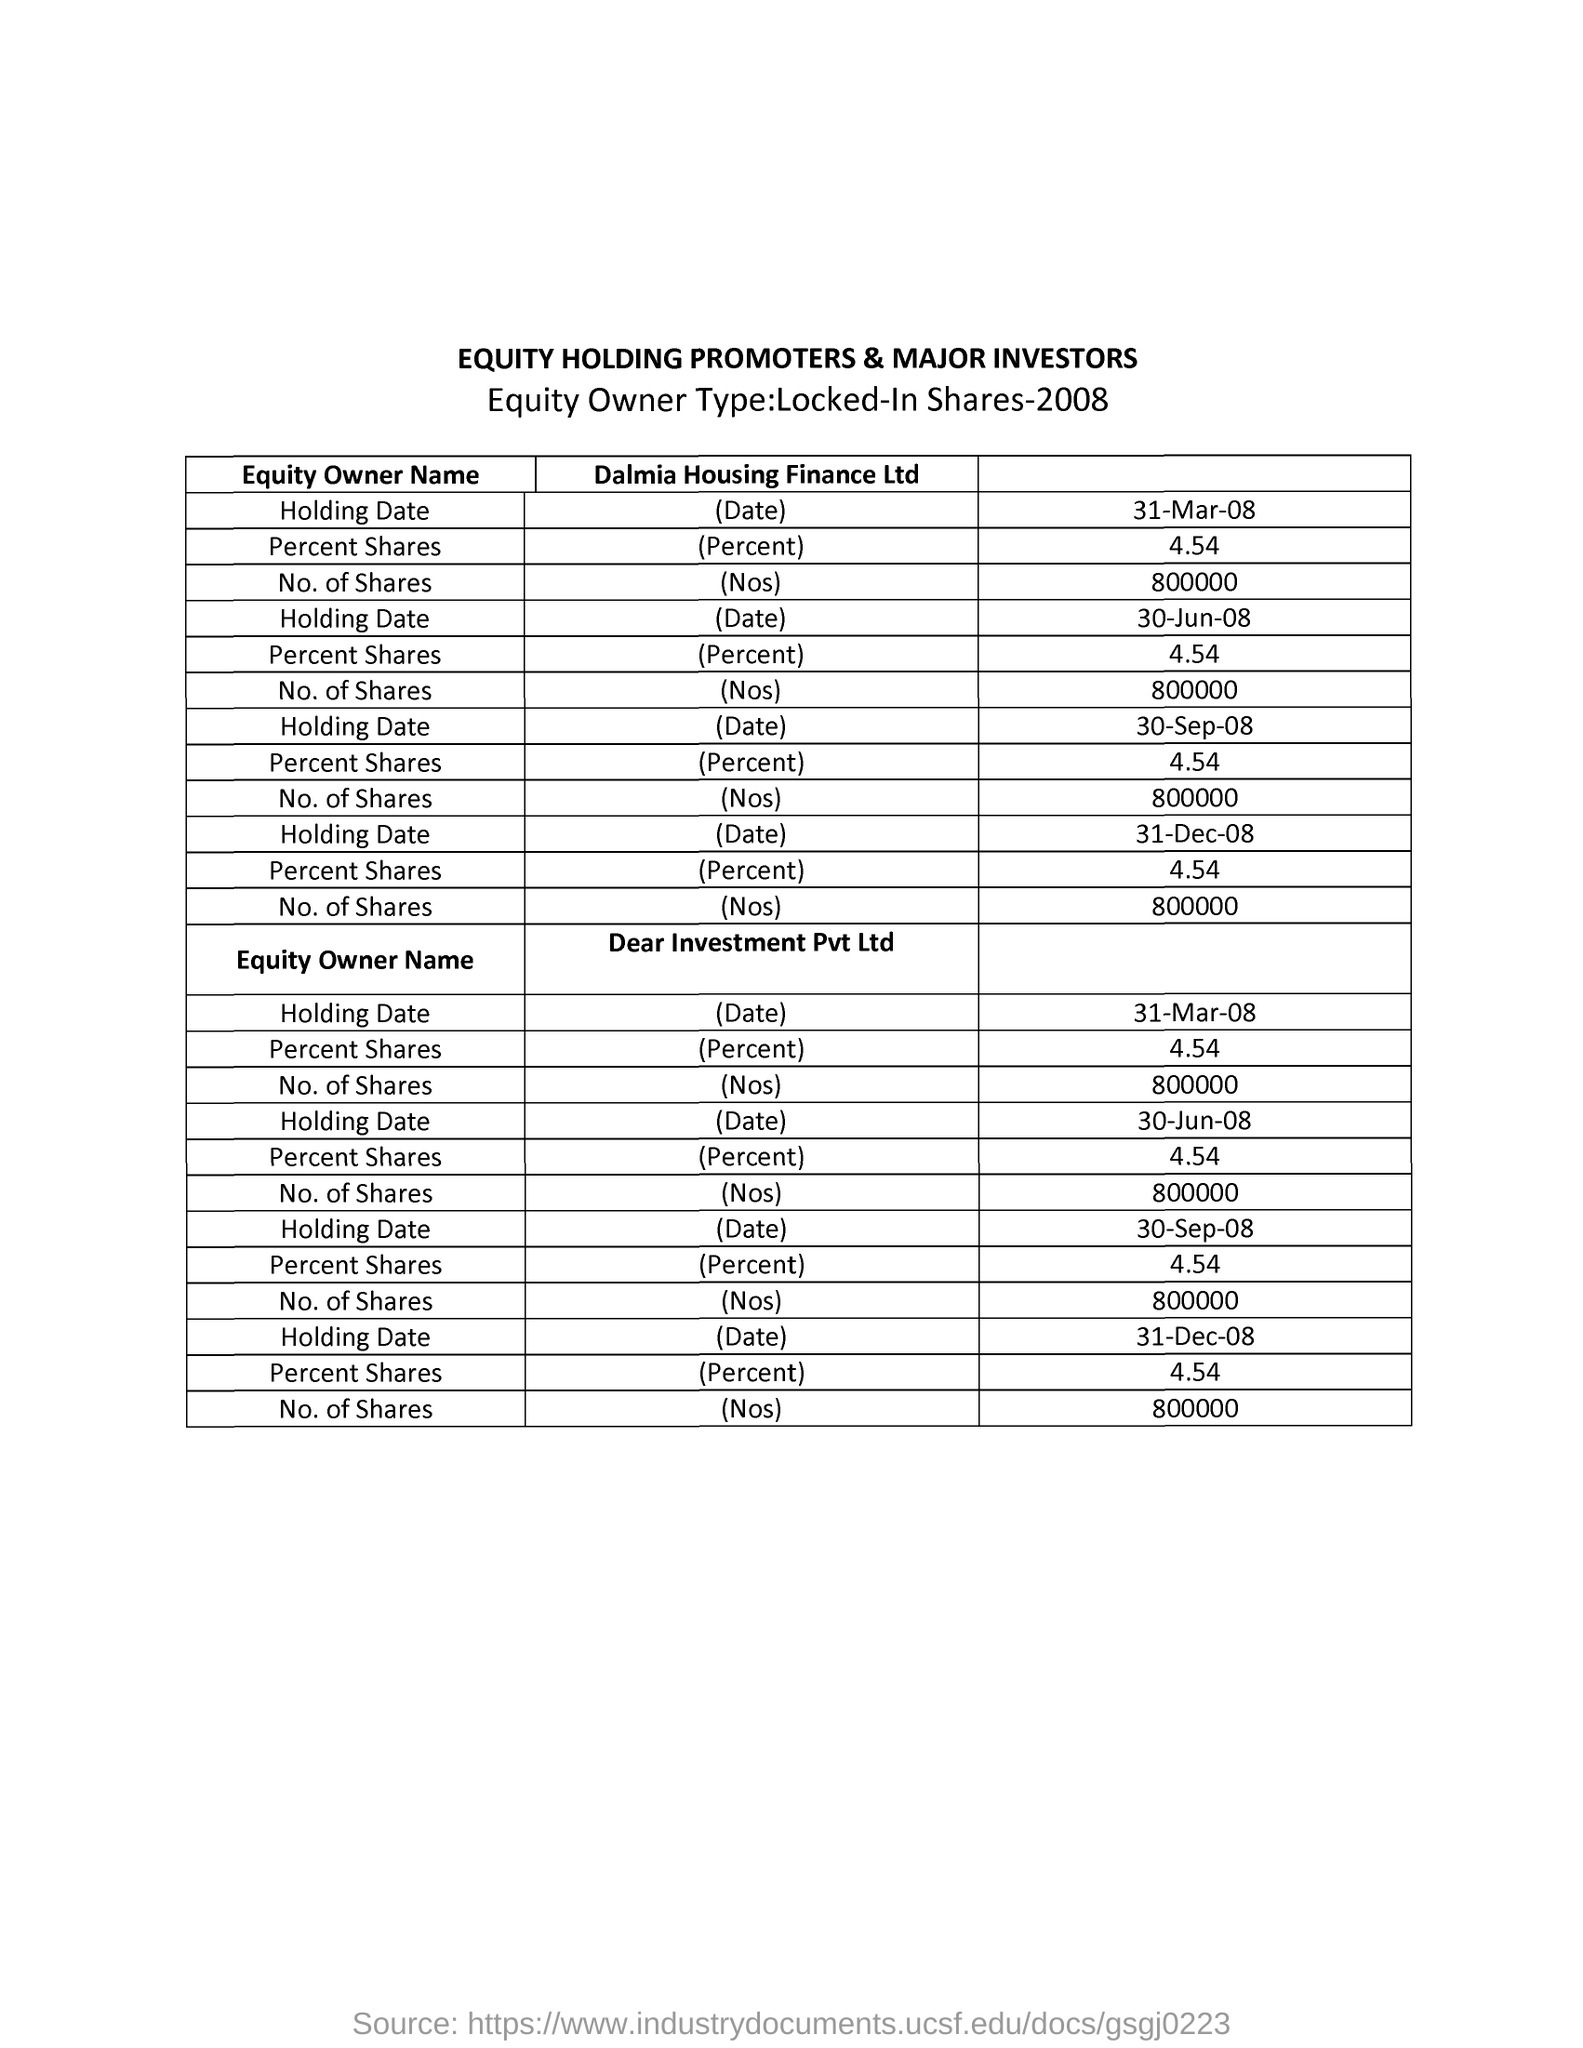What is the heading of the table written in capital letters?
Your answer should be compact. EQUITY HOLDING PROMOTERS & MAJOR INVESTORS. What is the first column heading of the table?
Your answer should be very brief. Equity Owner Name. What is the second column heading of the first table?
Offer a very short reply. Dalmia Housing Finance Ltd. For the "Holding Date " of 31-Mar-08 what PERCENT SHARES is given by "Dalmia Housing Finance Ltd"?
Offer a terse response. 4.54. For the "Holding Date " of 31-Mar-08  what is the number of shares of "Damia Housing Finance Ltd"?
Your answer should be very brief. 800000. What is the second column heading of the second table?
Make the answer very short. Dear Investment Pvt Ltd. "Locked-in Shares" detals  of which year is given in the table?
Your answer should be very brief. 2008. What is th last Holding Date of Equity Owner  mentioned for "Dalmia Housing Finance Ltd"?
Make the answer very short. 31-Dec-08. What is the first Holding Date of Equity Owner mentioned for "Dear Investment Pvt Ltd"?
Your response must be concise. 31-Mar-08. 